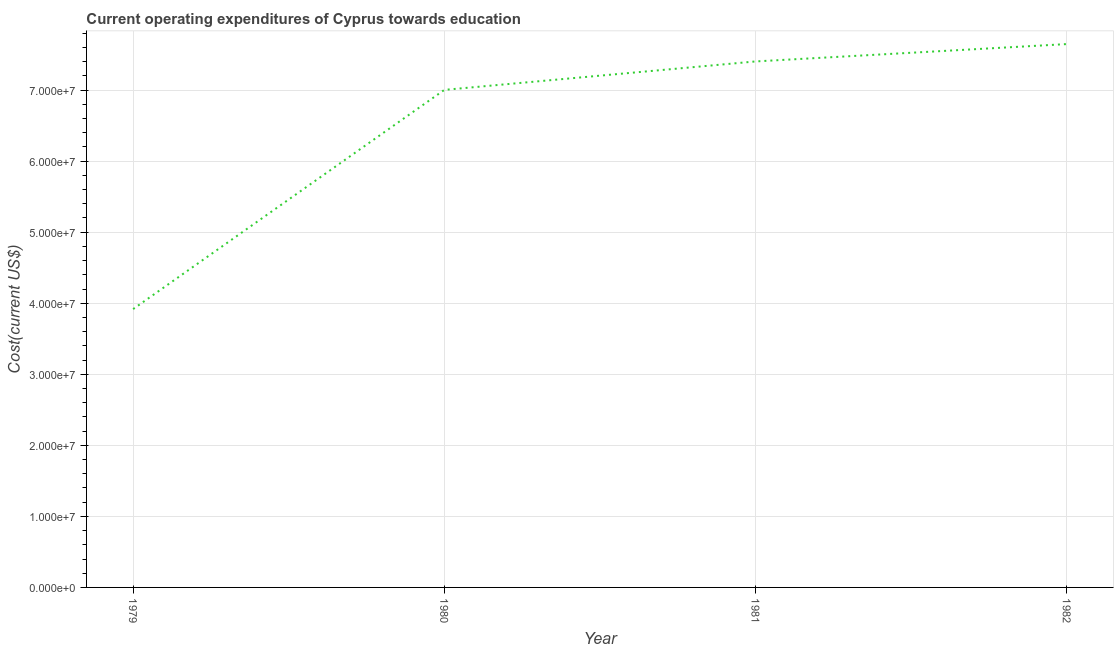What is the education expenditure in 1981?
Ensure brevity in your answer.  7.40e+07. Across all years, what is the maximum education expenditure?
Your response must be concise. 7.65e+07. Across all years, what is the minimum education expenditure?
Provide a short and direct response. 3.92e+07. In which year was the education expenditure maximum?
Provide a succinct answer. 1982. In which year was the education expenditure minimum?
Provide a succinct answer. 1979. What is the sum of the education expenditure?
Offer a terse response. 2.60e+08. What is the difference between the education expenditure in 1979 and 1980?
Ensure brevity in your answer.  -3.08e+07. What is the average education expenditure per year?
Give a very brief answer. 6.49e+07. What is the median education expenditure?
Your response must be concise. 7.20e+07. What is the ratio of the education expenditure in 1980 to that in 1981?
Give a very brief answer. 0.95. Is the education expenditure in 1979 less than that in 1980?
Your answer should be very brief. Yes. Is the difference between the education expenditure in 1979 and 1981 greater than the difference between any two years?
Your response must be concise. No. What is the difference between the highest and the second highest education expenditure?
Offer a very short reply. 2.44e+06. Is the sum of the education expenditure in 1979 and 1981 greater than the maximum education expenditure across all years?
Keep it short and to the point. Yes. What is the difference between the highest and the lowest education expenditure?
Your answer should be very brief. 3.73e+07. Does the education expenditure monotonically increase over the years?
Offer a very short reply. Yes. How many lines are there?
Ensure brevity in your answer.  1. How many years are there in the graph?
Ensure brevity in your answer.  4. What is the difference between two consecutive major ticks on the Y-axis?
Give a very brief answer. 1.00e+07. What is the title of the graph?
Offer a terse response. Current operating expenditures of Cyprus towards education. What is the label or title of the Y-axis?
Your response must be concise. Cost(current US$). What is the Cost(current US$) in 1979?
Offer a terse response. 3.92e+07. What is the Cost(current US$) in 1980?
Your answer should be compact. 7.00e+07. What is the Cost(current US$) in 1981?
Provide a succinct answer. 7.40e+07. What is the Cost(current US$) in 1982?
Keep it short and to the point. 7.65e+07. What is the difference between the Cost(current US$) in 1979 and 1980?
Give a very brief answer. -3.08e+07. What is the difference between the Cost(current US$) in 1979 and 1981?
Your answer should be compact. -3.49e+07. What is the difference between the Cost(current US$) in 1979 and 1982?
Provide a short and direct response. -3.73e+07. What is the difference between the Cost(current US$) in 1980 and 1981?
Provide a succinct answer. -4.00e+06. What is the difference between the Cost(current US$) in 1980 and 1982?
Your answer should be very brief. -6.45e+06. What is the difference between the Cost(current US$) in 1981 and 1982?
Offer a very short reply. -2.44e+06. What is the ratio of the Cost(current US$) in 1979 to that in 1980?
Your response must be concise. 0.56. What is the ratio of the Cost(current US$) in 1979 to that in 1981?
Keep it short and to the point. 0.53. What is the ratio of the Cost(current US$) in 1979 to that in 1982?
Provide a succinct answer. 0.51. What is the ratio of the Cost(current US$) in 1980 to that in 1981?
Make the answer very short. 0.95. What is the ratio of the Cost(current US$) in 1980 to that in 1982?
Offer a terse response. 0.92. What is the ratio of the Cost(current US$) in 1981 to that in 1982?
Provide a succinct answer. 0.97. 